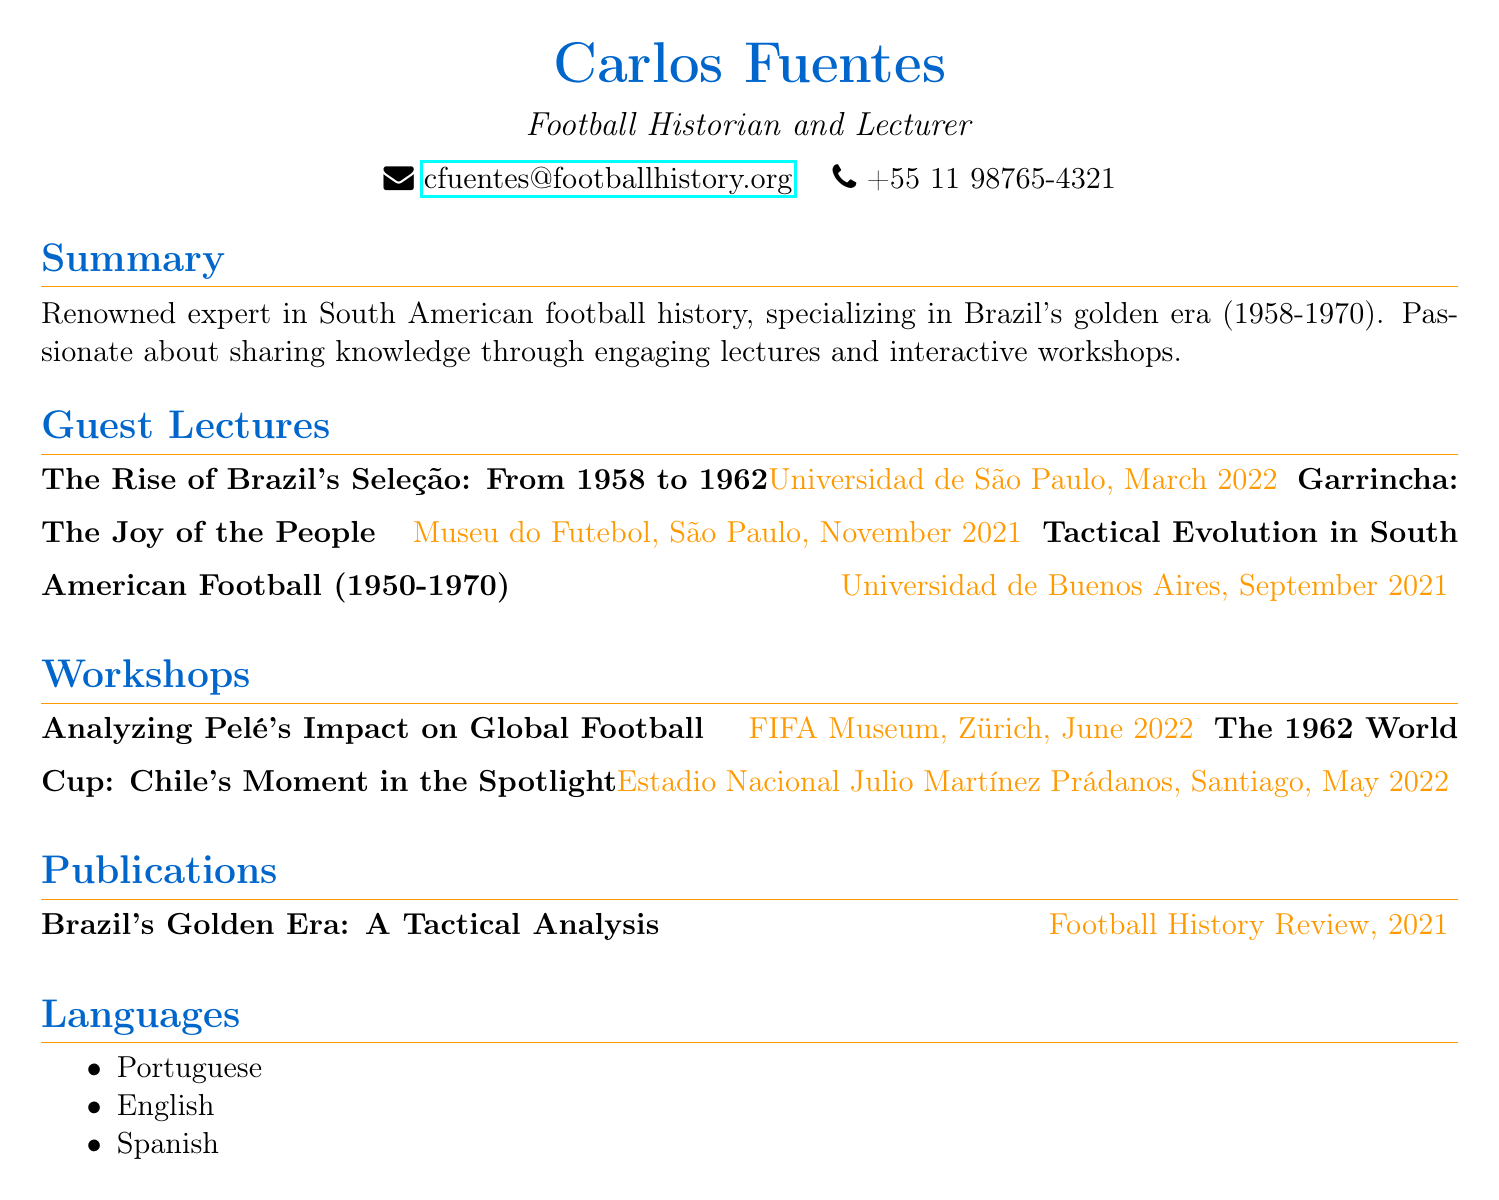what is the name of the lecturer? The lecturer's name is stated at the beginning of the document.
Answer: Carlos Fuentes what is the title of the workshop conducted in Zurich? The specific workshop title can be found in the workshops section.
Answer: Analyzing Pelé's Impact on Global Football when was the guest lecture on Garrincha held? The date of the guest lecture on Garrincha is listed next to its title.
Answer: November 2021 which institution hosted the lecture titled "The Rise of Brazil's Seleção: From 1958 to 1962"? The institution is mentioned directly beside the title in the guest lectures section.
Answer: Universidad de São Paulo how many languages does Carlos Fuentes speak? The number of languages spoken is listed in the languages section.
Answer: Three what is the focus period of Brazil's golden era mentioned in the summary? The focus period is indicated in the summary section of the document.
Answer: 1958-1970 which publication is authored by Carlos Fuentes? The title of the publication is mentioned in the publications section.
Answer: Brazil's Golden Era: A Tactical Analysis what venue hosted the workshop on the 1962 World Cup? The venue for the workshop is found in the workshops section.
Answer: Estadio Nacional Julio Martínez Prádanos, Santiago when was the tactical evolution lecture conducted? The date for the tactical evolution lecture is provided in the guest lectures section.
Answer: September 2021 